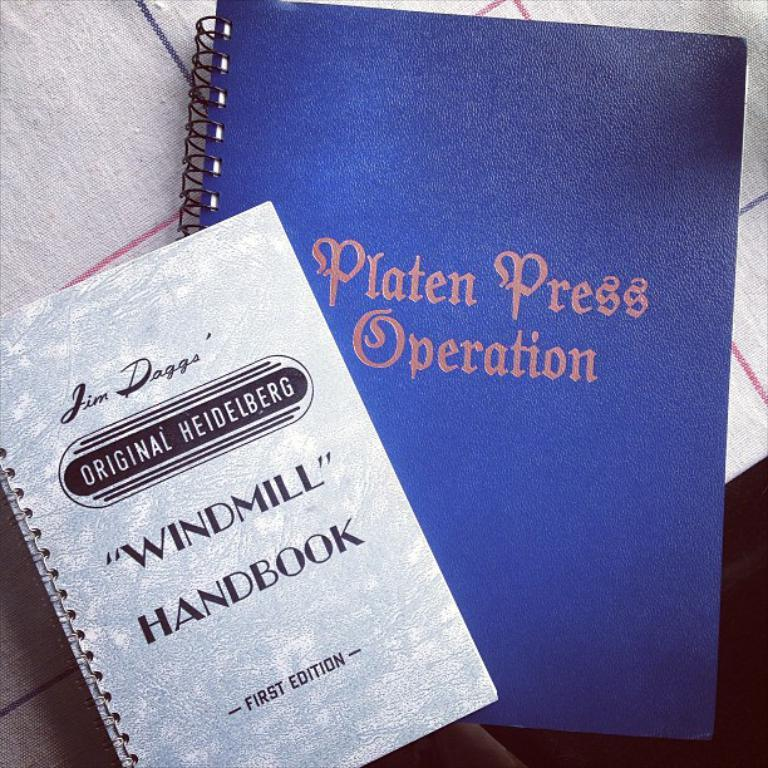What objects can be seen in the image? There are books in the image. Where are the books located? The books are placed on a surface. What type of rock is present in the image? There is no rock present in the image; it only features books placed on a surface. 